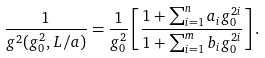Convert formula to latex. <formula><loc_0><loc_0><loc_500><loc_500>\frac { 1 } { g ^ { 2 } ( g _ { 0 } ^ { 2 } , L / a ) } = \frac { 1 } { g _ { 0 } ^ { 2 } } \left [ \frac { 1 + \sum _ { i = 1 } ^ { n } a _ { i } g _ { 0 } ^ { 2 i } } { 1 + \sum _ { i = 1 } ^ { m } b _ { i } g _ { 0 } ^ { 2 i } } \right ] .</formula> 